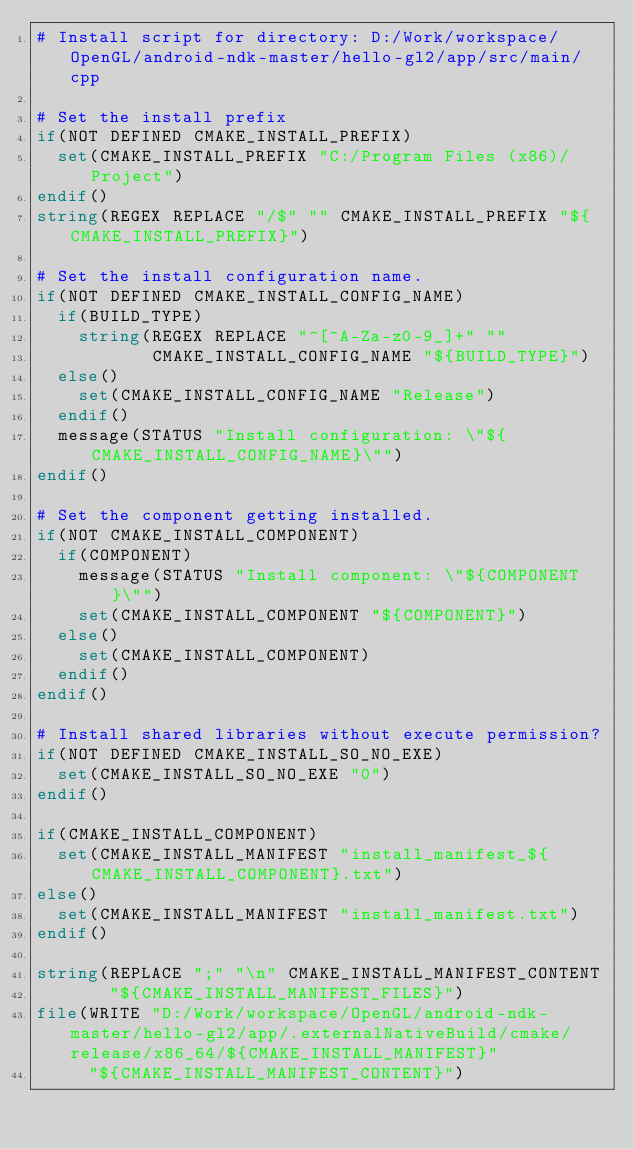<code> <loc_0><loc_0><loc_500><loc_500><_CMake_># Install script for directory: D:/Work/workspace/OpenGL/android-ndk-master/hello-gl2/app/src/main/cpp

# Set the install prefix
if(NOT DEFINED CMAKE_INSTALL_PREFIX)
  set(CMAKE_INSTALL_PREFIX "C:/Program Files (x86)/Project")
endif()
string(REGEX REPLACE "/$" "" CMAKE_INSTALL_PREFIX "${CMAKE_INSTALL_PREFIX}")

# Set the install configuration name.
if(NOT DEFINED CMAKE_INSTALL_CONFIG_NAME)
  if(BUILD_TYPE)
    string(REGEX REPLACE "^[^A-Za-z0-9_]+" ""
           CMAKE_INSTALL_CONFIG_NAME "${BUILD_TYPE}")
  else()
    set(CMAKE_INSTALL_CONFIG_NAME "Release")
  endif()
  message(STATUS "Install configuration: \"${CMAKE_INSTALL_CONFIG_NAME}\"")
endif()

# Set the component getting installed.
if(NOT CMAKE_INSTALL_COMPONENT)
  if(COMPONENT)
    message(STATUS "Install component: \"${COMPONENT}\"")
    set(CMAKE_INSTALL_COMPONENT "${COMPONENT}")
  else()
    set(CMAKE_INSTALL_COMPONENT)
  endif()
endif()

# Install shared libraries without execute permission?
if(NOT DEFINED CMAKE_INSTALL_SO_NO_EXE)
  set(CMAKE_INSTALL_SO_NO_EXE "0")
endif()

if(CMAKE_INSTALL_COMPONENT)
  set(CMAKE_INSTALL_MANIFEST "install_manifest_${CMAKE_INSTALL_COMPONENT}.txt")
else()
  set(CMAKE_INSTALL_MANIFEST "install_manifest.txt")
endif()

string(REPLACE ";" "\n" CMAKE_INSTALL_MANIFEST_CONTENT
       "${CMAKE_INSTALL_MANIFEST_FILES}")
file(WRITE "D:/Work/workspace/OpenGL/android-ndk-master/hello-gl2/app/.externalNativeBuild/cmake/release/x86_64/${CMAKE_INSTALL_MANIFEST}"
     "${CMAKE_INSTALL_MANIFEST_CONTENT}")
</code> 